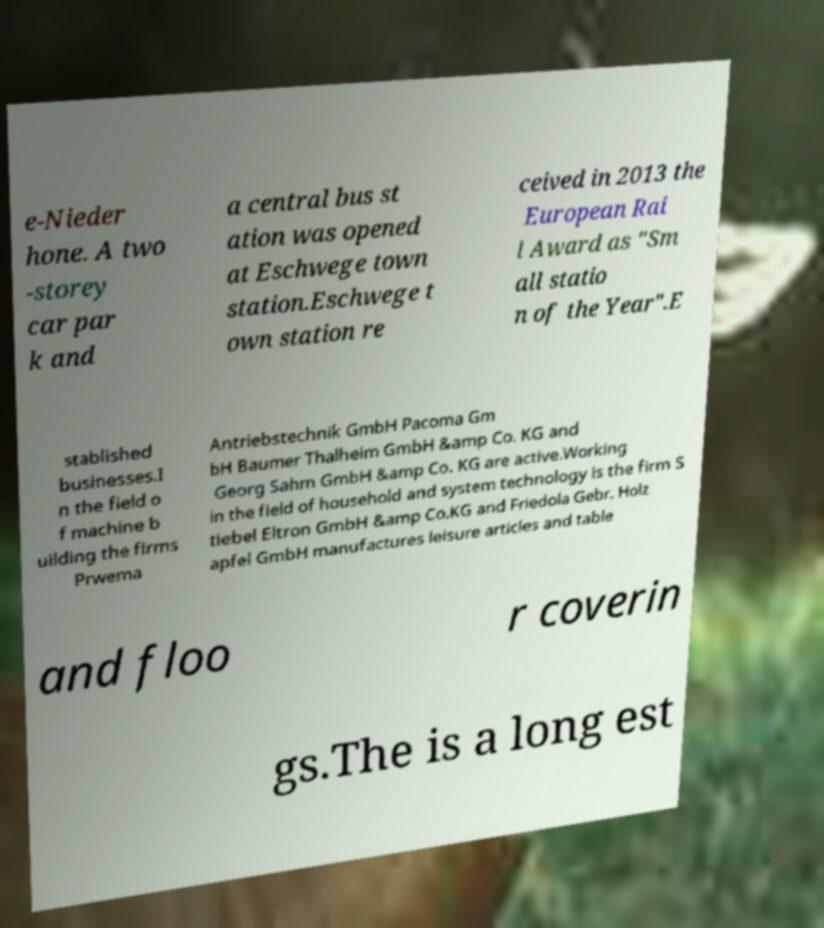There's text embedded in this image that I need extracted. Can you transcribe it verbatim? e-Nieder hone. A two -storey car par k and a central bus st ation was opened at Eschwege town station.Eschwege t own station re ceived in 2013 the European Rai l Award as "Sm all statio n of the Year".E stablished businesses.I n the field o f machine b uilding the firms Prwema Antriebstechnik GmbH Pacoma Gm bH Baumer Thalheim GmbH &amp Co. KG and Georg Sahm GmbH &amp Co. KG are active.Working in the field of household and system technology is the firm S tiebel Eltron GmbH &amp Co.KG and Friedola Gebr. Holz apfel GmbH manufactures leisure articles and table and floo r coverin gs.The is a long est 